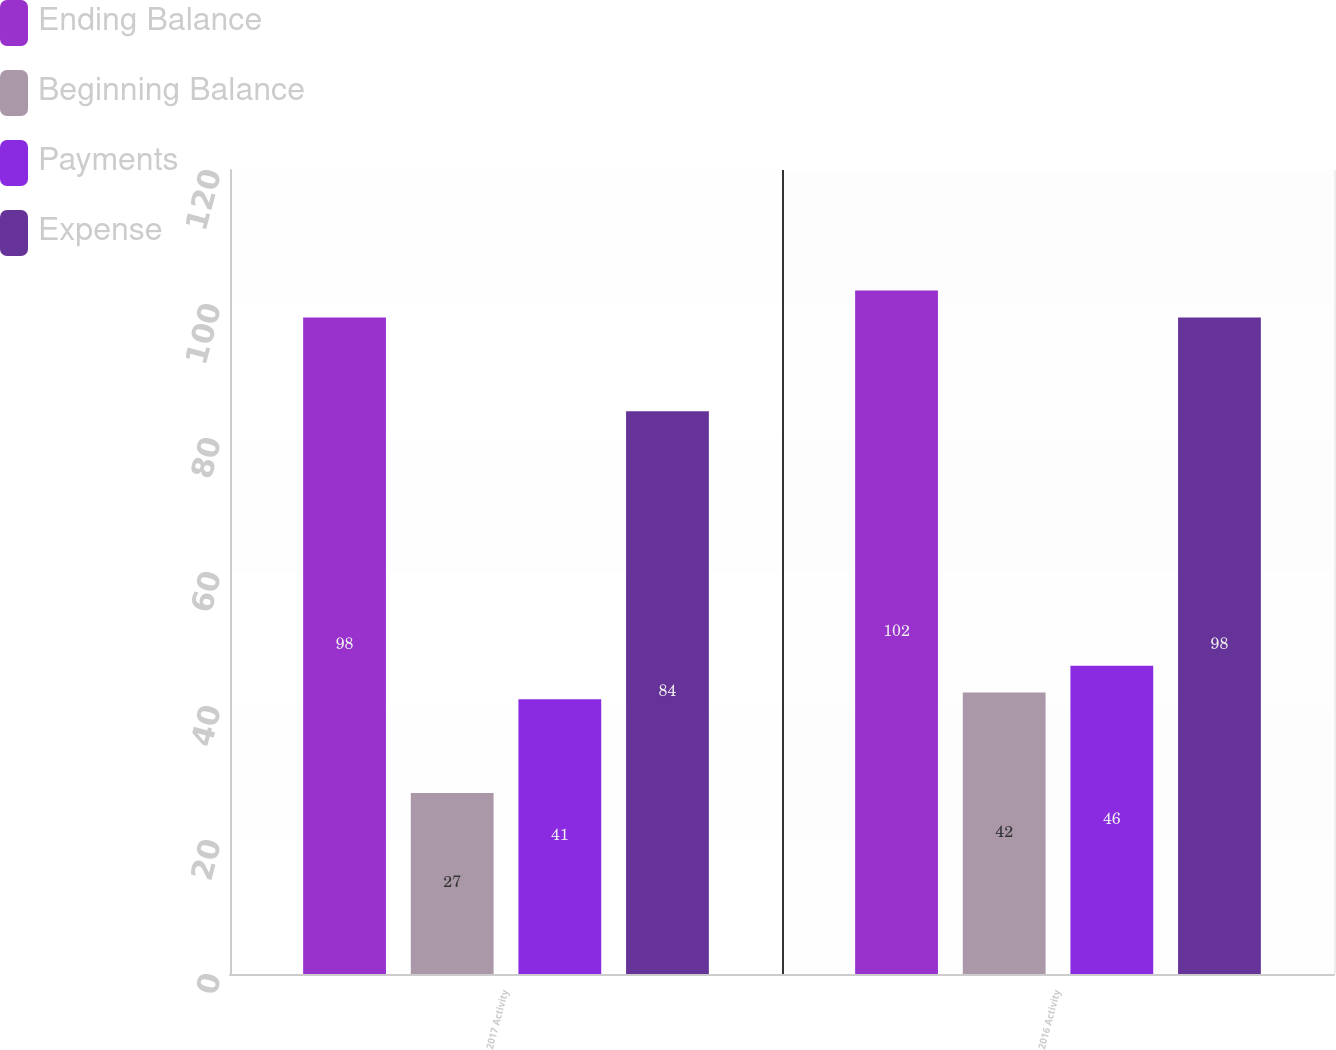Convert chart to OTSL. <chart><loc_0><loc_0><loc_500><loc_500><stacked_bar_chart><ecel><fcel>2017 Activity<fcel>2016 Activity<nl><fcel>Ending Balance<fcel>98<fcel>102<nl><fcel>Beginning Balance<fcel>27<fcel>42<nl><fcel>Payments<fcel>41<fcel>46<nl><fcel>Expense<fcel>84<fcel>98<nl></chart> 